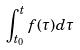Convert formula to latex. <formula><loc_0><loc_0><loc_500><loc_500>\int _ { t _ { 0 } } ^ { t } f ( \tau ) d \tau</formula> 